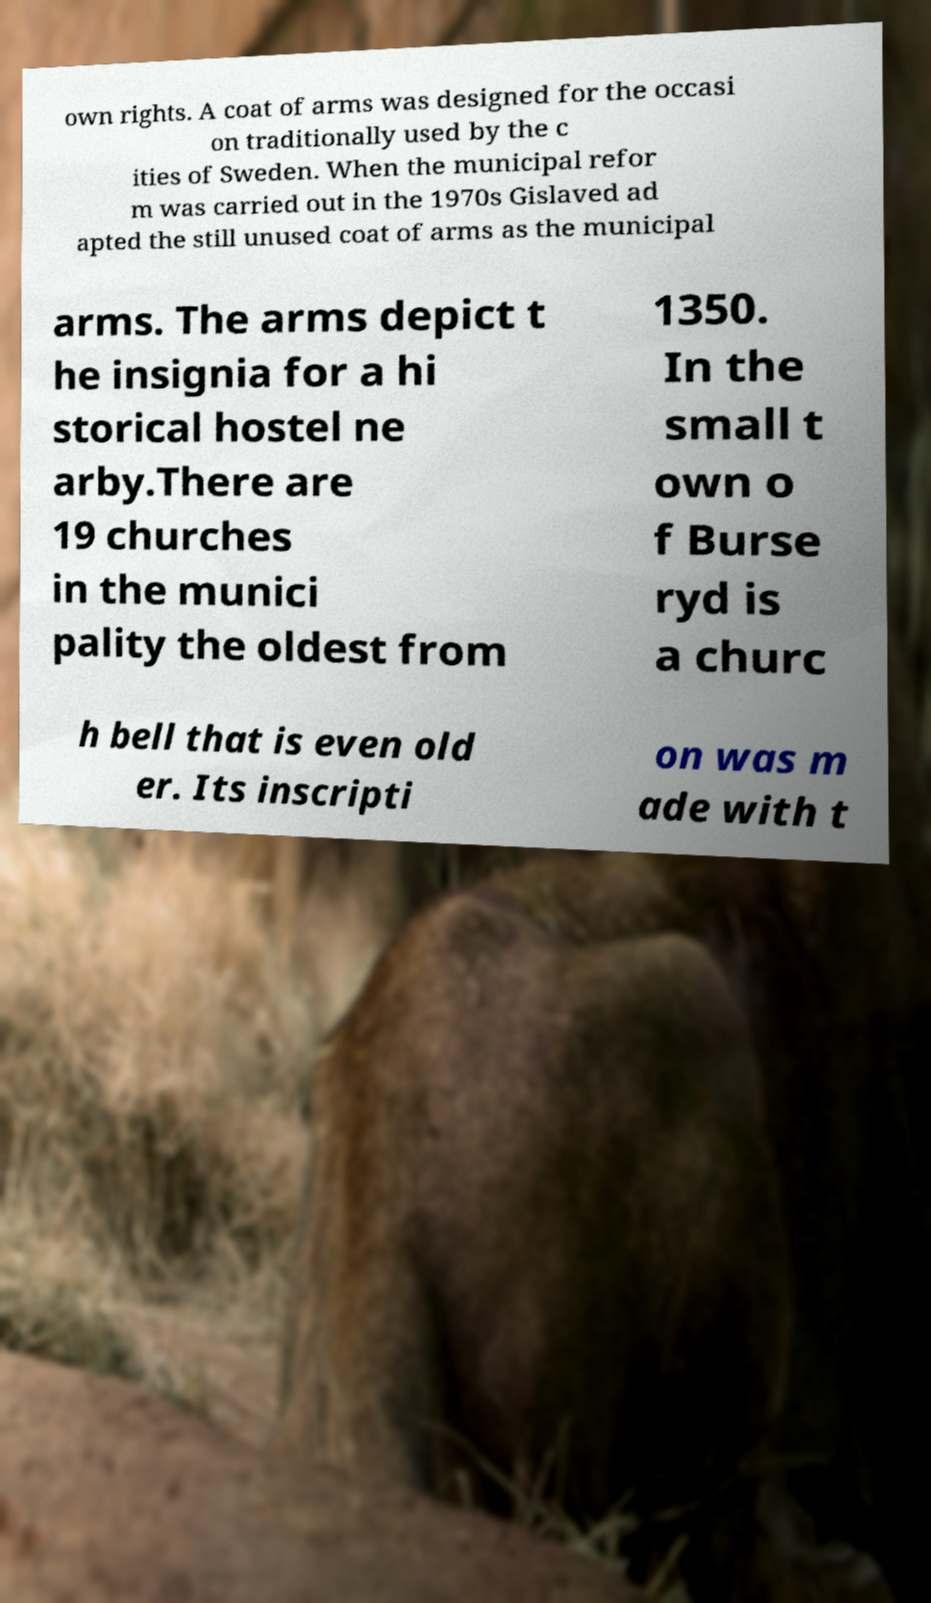Could you assist in decoding the text presented in this image and type it out clearly? own rights. A coat of arms was designed for the occasi on traditionally used by the c ities of Sweden. When the municipal refor m was carried out in the 1970s Gislaved ad apted the still unused coat of arms as the municipal arms. The arms depict t he insignia for a hi storical hostel ne arby.There are 19 churches in the munici pality the oldest from 1350. In the small t own o f Burse ryd is a churc h bell that is even old er. Its inscripti on was m ade with t 